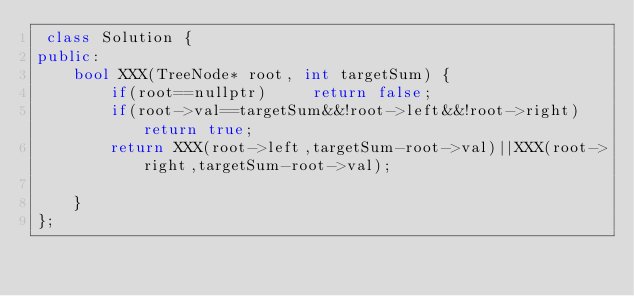Convert code to text. <code><loc_0><loc_0><loc_500><loc_500><_C++_> class Solution {
public:
    bool XXX(TreeNode* root, int targetSum) {
        if(root==nullptr)     return false;
        if(root->val==targetSum&&!root->left&&!root->right) return true;
        return XXX(root->left,targetSum-root->val)||XXX(root->right,targetSum-root->val);

    }
};

</code> 